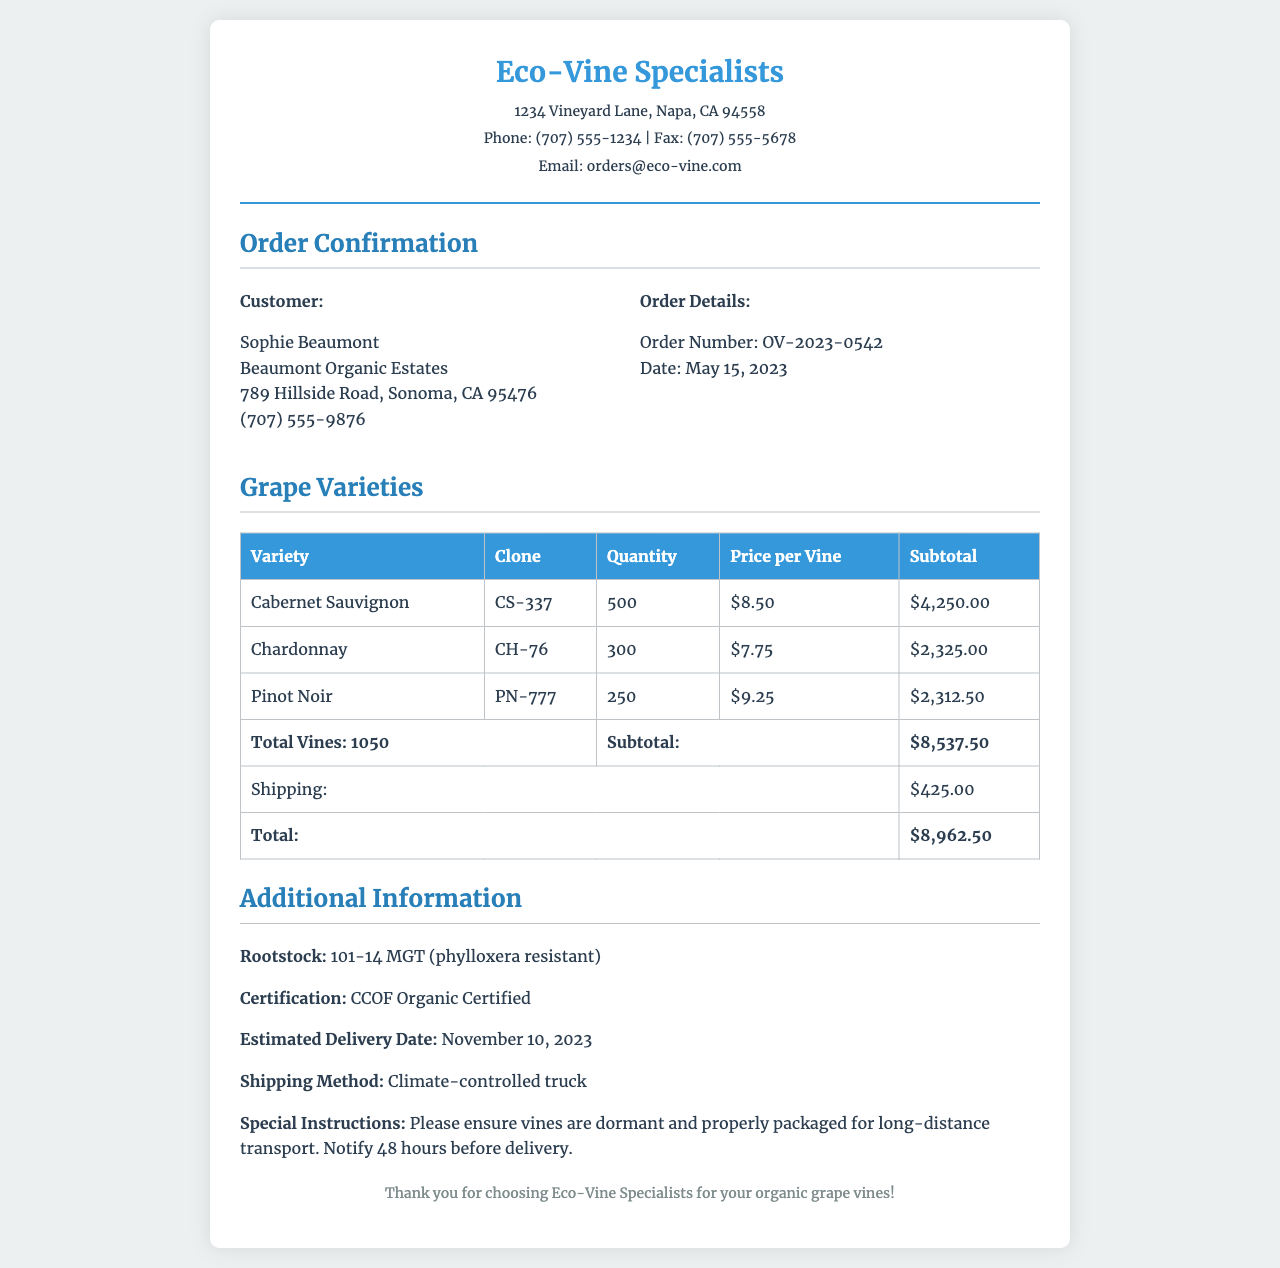What is the order number? The order number is specified in the order details section of the document as OV-2023-0542.
Answer: OV-2023-0542 How many Cabernet Sauvignon vines were ordered? The quantity of Cabernet Sauvignon vines is listed in the table of grape varieties as 500.
Answer: 500 What is the estimated delivery date? The estimated delivery date is mentioned in the additional information section as November 10, 2023.
Answer: November 10, 2023 What is the total amount due for the order? The total amount due is provided in the totals section of the document as $8,962.50.
Answer: $8,962.50 Who is the customer? The customer’s name is stated at the beginning of the customer information section as Sophie Beaumont.
Answer: Sophie Beaumont What is the shipping method? The shipping method is described in the additional information section as climate-controlled truck.
Answer: Climate-controlled truck How many total vines were ordered? The total number of vines is calculated in the subtotal row of the table as 1050.
Answer: 1050 What is the price per vine for Chardonnay? The price per vine for Chardonnay is indicated in the table as $7.75.
Answer: $7.75 What is the rootstock used for the grape vines? The rootstock for the grape vines is specified in the additional information section as 101-14 MGT.
Answer: 101-14 MGT 